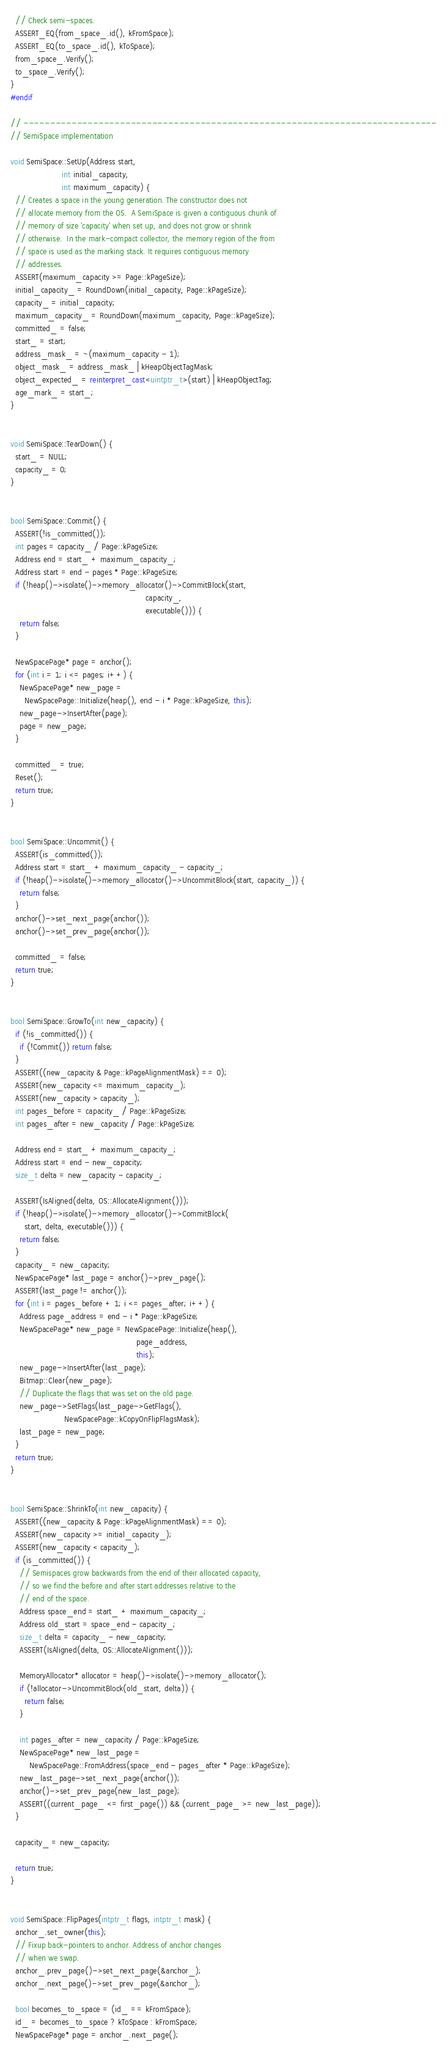<code> <loc_0><loc_0><loc_500><loc_500><_C++_>  // Check semi-spaces.
  ASSERT_EQ(from_space_.id(), kFromSpace);
  ASSERT_EQ(to_space_.id(), kToSpace);
  from_space_.Verify();
  to_space_.Verify();
}
#endif

// -----------------------------------------------------------------------------
// SemiSpace implementation

void SemiSpace::SetUp(Address start,
                      int initial_capacity,
                      int maximum_capacity) {
  // Creates a space in the young generation. The constructor does not
  // allocate memory from the OS.  A SemiSpace is given a contiguous chunk of
  // memory of size 'capacity' when set up, and does not grow or shrink
  // otherwise.  In the mark-compact collector, the memory region of the from
  // space is used as the marking stack. It requires contiguous memory
  // addresses.
  ASSERT(maximum_capacity >= Page::kPageSize);
  initial_capacity_ = RoundDown(initial_capacity, Page::kPageSize);
  capacity_ = initial_capacity;
  maximum_capacity_ = RoundDown(maximum_capacity, Page::kPageSize);
  committed_ = false;
  start_ = start;
  address_mask_ = ~(maximum_capacity - 1);
  object_mask_ = address_mask_ | kHeapObjectTagMask;
  object_expected_ = reinterpret_cast<uintptr_t>(start) | kHeapObjectTag;
  age_mark_ = start_;
}


void SemiSpace::TearDown() {
  start_ = NULL;
  capacity_ = 0;
}


bool SemiSpace::Commit() {
  ASSERT(!is_committed());
  int pages = capacity_ / Page::kPageSize;
  Address end = start_ + maximum_capacity_;
  Address start = end - pages * Page::kPageSize;
  if (!heap()->isolate()->memory_allocator()->CommitBlock(start,
                                                          capacity_,
                                                          executable())) {
    return false;
  }

  NewSpacePage* page = anchor();
  for (int i = 1; i <= pages; i++) {
    NewSpacePage* new_page =
      NewSpacePage::Initialize(heap(), end - i * Page::kPageSize, this);
    new_page->InsertAfter(page);
    page = new_page;
  }

  committed_ = true;
  Reset();
  return true;
}


bool SemiSpace::Uncommit() {
  ASSERT(is_committed());
  Address start = start_ + maximum_capacity_ - capacity_;
  if (!heap()->isolate()->memory_allocator()->UncommitBlock(start, capacity_)) {
    return false;
  }
  anchor()->set_next_page(anchor());
  anchor()->set_prev_page(anchor());

  committed_ = false;
  return true;
}


bool SemiSpace::GrowTo(int new_capacity) {
  if (!is_committed()) {
    if (!Commit()) return false;
  }
  ASSERT((new_capacity & Page::kPageAlignmentMask) == 0);
  ASSERT(new_capacity <= maximum_capacity_);
  ASSERT(new_capacity > capacity_);
  int pages_before = capacity_ / Page::kPageSize;
  int pages_after = new_capacity / Page::kPageSize;

  Address end = start_ + maximum_capacity_;
  Address start = end - new_capacity;
  size_t delta = new_capacity - capacity_;

  ASSERT(IsAligned(delta, OS::AllocateAlignment()));
  if (!heap()->isolate()->memory_allocator()->CommitBlock(
      start, delta, executable())) {
    return false;
  }
  capacity_ = new_capacity;
  NewSpacePage* last_page = anchor()->prev_page();
  ASSERT(last_page != anchor());
  for (int i = pages_before + 1; i <= pages_after; i++) {
    Address page_address = end - i * Page::kPageSize;
    NewSpacePage* new_page = NewSpacePage::Initialize(heap(),
                                                      page_address,
                                                      this);
    new_page->InsertAfter(last_page);
    Bitmap::Clear(new_page);
    // Duplicate the flags that was set on the old page.
    new_page->SetFlags(last_page->GetFlags(),
                       NewSpacePage::kCopyOnFlipFlagsMask);
    last_page = new_page;
  }
  return true;
}


bool SemiSpace::ShrinkTo(int new_capacity) {
  ASSERT((new_capacity & Page::kPageAlignmentMask) == 0);
  ASSERT(new_capacity >= initial_capacity_);
  ASSERT(new_capacity < capacity_);
  if (is_committed()) {
    // Semispaces grow backwards from the end of their allocated capacity,
    // so we find the before and after start addresses relative to the
    // end of the space.
    Address space_end = start_ + maximum_capacity_;
    Address old_start = space_end - capacity_;
    size_t delta = capacity_ - new_capacity;
    ASSERT(IsAligned(delta, OS::AllocateAlignment()));

    MemoryAllocator* allocator = heap()->isolate()->memory_allocator();
    if (!allocator->UncommitBlock(old_start, delta)) {
      return false;
    }

    int pages_after = new_capacity / Page::kPageSize;
    NewSpacePage* new_last_page =
        NewSpacePage::FromAddress(space_end - pages_after * Page::kPageSize);
    new_last_page->set_next_page(anchor());
    anchor()->set_prev_page(new_last_page);
    ASSERT((current_page_ <= first_page()) && (current_page_ >= new_last_page));
  }

  capacity_ = new_capacity;

  return true;
}


void SemiSpace::FlipPages(intptr_t flags, intptr_t mask) {
  anchor_.set_owner(this);
  // Fixup back-pointers to anchor. Address of anchor changes
  // when we swap.
  anchor_.prev_page()->set_next_page(&anchor_);
  anchor_.next_page()->set_prev_page(&anchor_);

  bool becomes_to_space = (id_ == kFromSpace);
  id_ = becomes_to_space ? kToSpace : kFromSpace;
  NewSpacePage* page = anchor_.next_page();</code> 